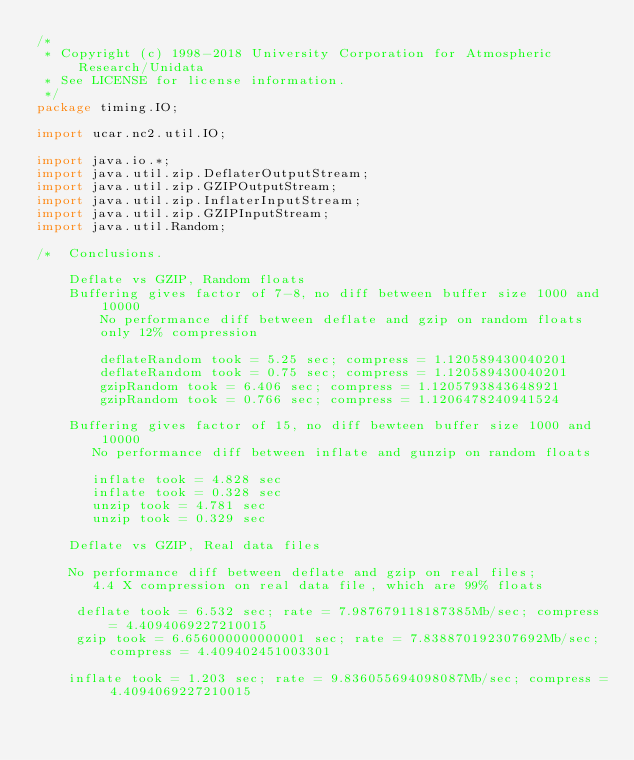<code> <loc_0><loc_0><loc_500><loc_500><_Java_>/*
 * Copyright (c) 1998-2018 University Corporation for Atmospheric Research/Unidata
 * See LICENSE for license information.
 */
package timing.IO;

import ucar.nc2.util.IO;

import java.io.*;
import java.util.zip.DeflaterOutputStream;
import java.util.zip.GZIPOutputStream;
import java.util.zip.InflaterInputStream;
import java.util.zip.GZIPInputStream;
import java.util.Random;

/*  Conclusions.

    Deflate vs GZIP, Random floats
    Buffering gives factor of 7-8, no diff between buffer size 1000 and 10000
        No performance diff between deflate and gzip on random floats
        only 12% compression

        deflateRandom took = 5.25 sec; compress = 1.120589430040201
        deflateRandom took = 0.75 sec; compress = 1.120589430040201
        gzipRandom took = 6.406 sec; compress = 1.1205793843648921
        gzipRandom took = 0.766 sec; compress = 1.1206478240941524

    Buffering gives factor of 15, no diff bewteen buffer size 1000 and 10000
       No performance diff between inflate and gunzip on random floats

       inflate took = 4.828 sec
       inflate took = 0.328 sec
       unzip took = 4.781 sec
       unzip took = 0.329 sec

    Deflate vs GZIP, Real data files

    No performance diff between deflate and gzip on real files;
       4.4 X compression on real data file, which are 99% floats

     deflate took = 6.532 sec; rate = 7.987679118187385Mb/sec; compress = 4.4094069227210015
     gzip took = 6.656000000000001 sec; rate = 7.838870192307692Mb/sec; compress = 4.409402451003301

    inflate took = 1.203 sec; rate = 9.836055694098087Mb/sec; compress = 4.4094069227210015</code> 